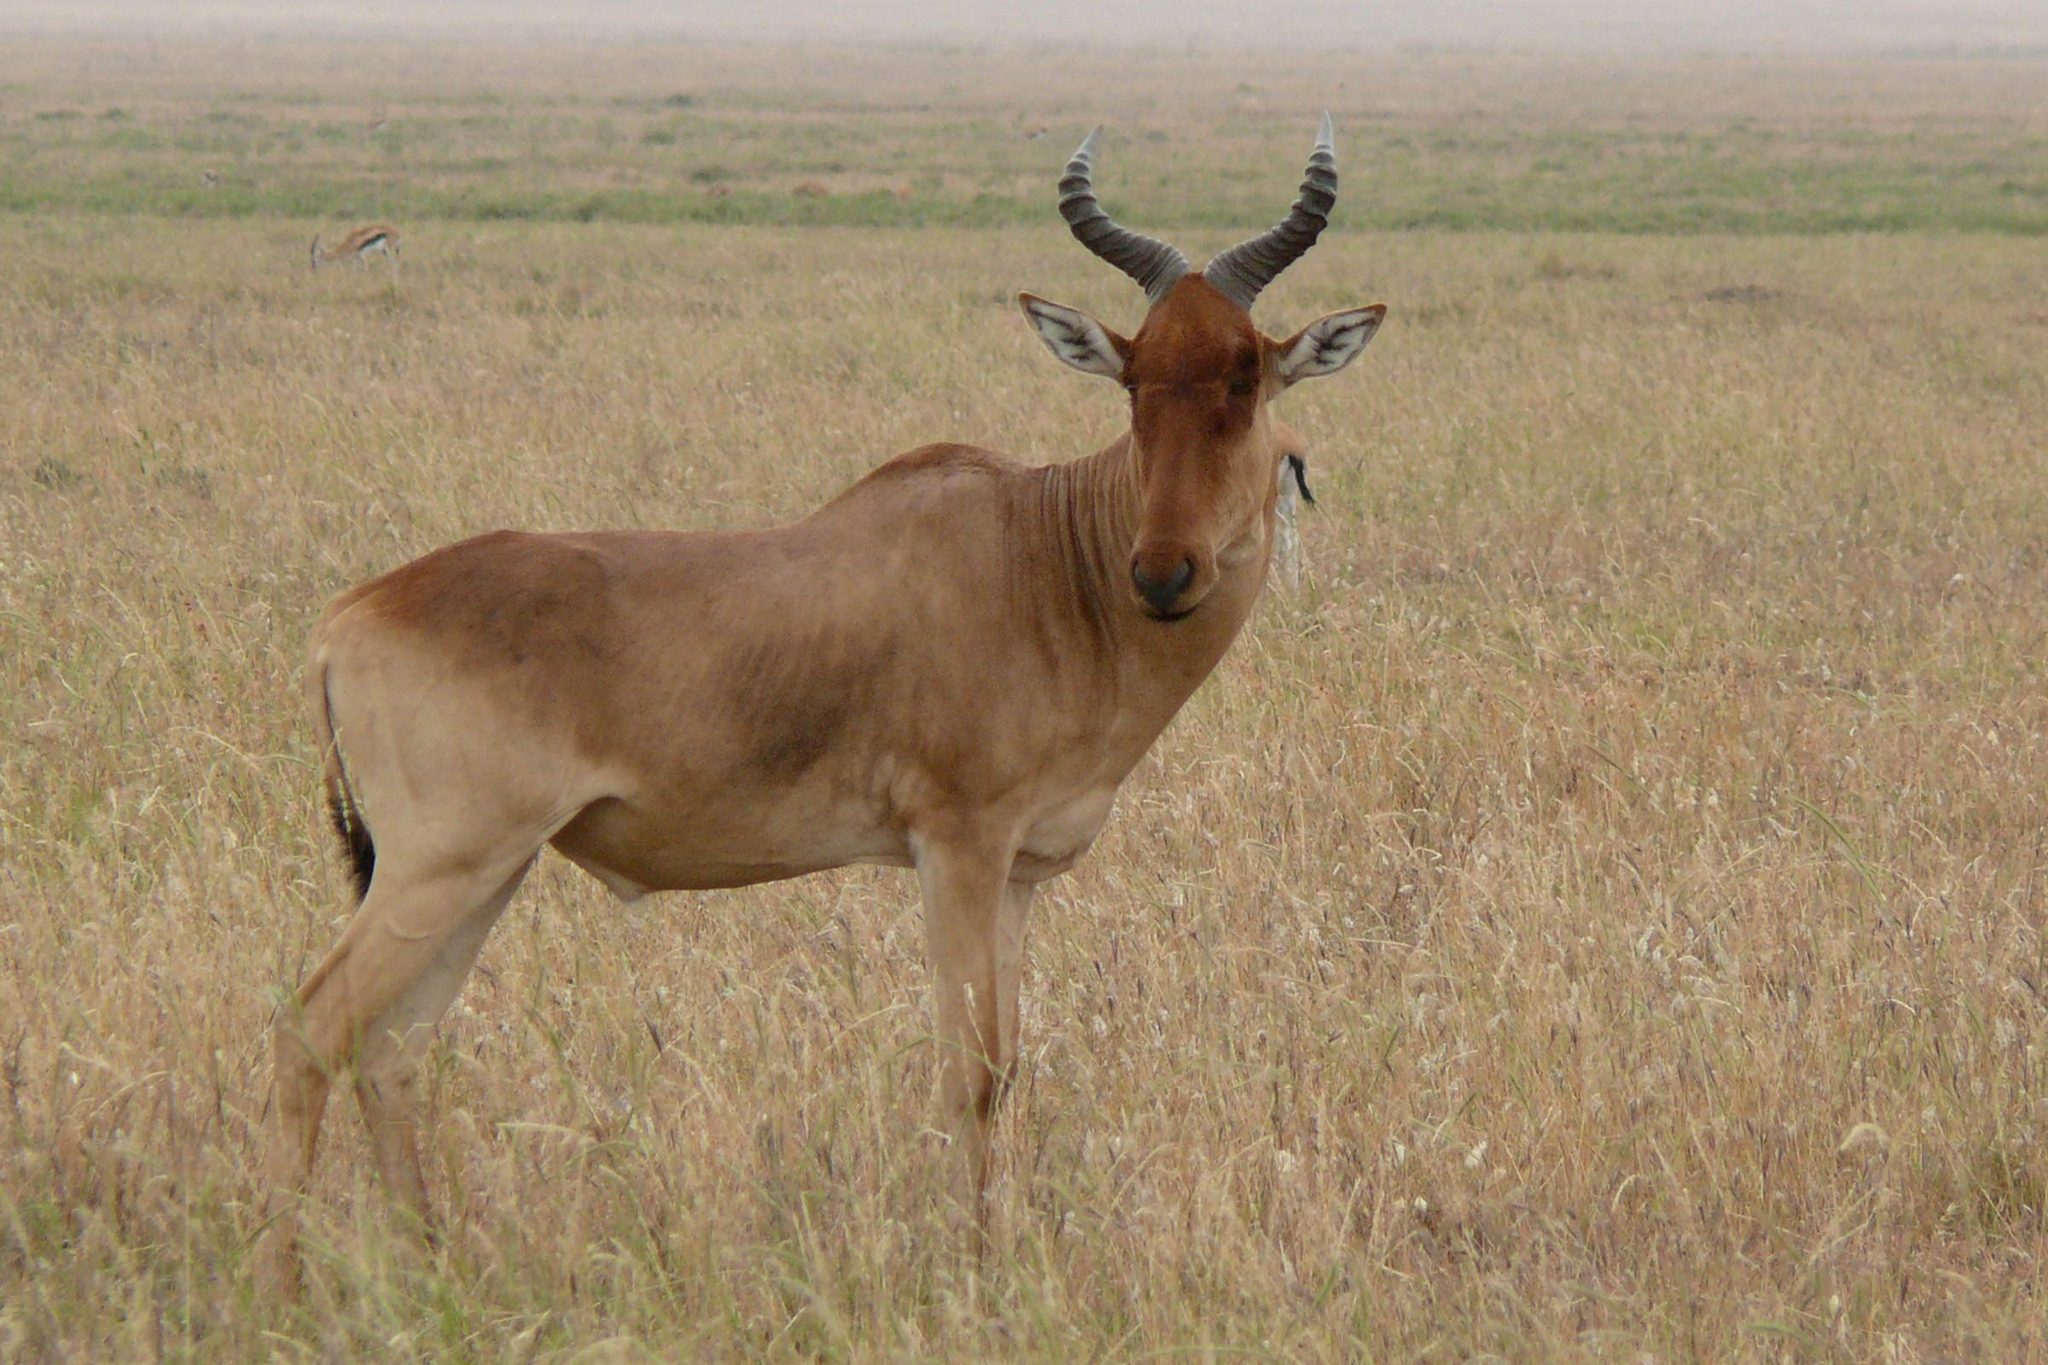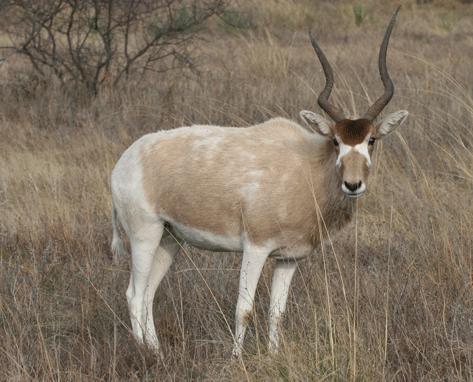The first image is the image on the left, the second image is the image on the right. Evaluate the accuracy of this statement regarding the images: "There are two animals in total.". Is it true? Answer yes or no. Yes. 